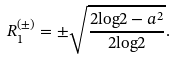<formula> <loc_0><loc_0><loc_500><loc_500>R _ { 1 } ^ { ( \pm ) } = { \pm } \sqrt { \frac { 2 { \log } 2 - a ^ { 2 } } { 2 { \log } 2 } } .</formula> 